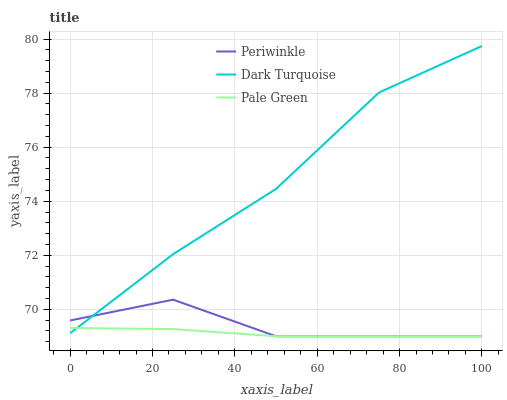Does Pale Green have the minimum area under the curve?
Answer yes or no. Yes. Does Dark Turquoise have the maximum area under the curve?
Answer yes or no. Yes. Does Periwinkle have the minimum area under the curve?
Answer yes or no. No. Does Periwinkle have the maximum area under the curve?
Answer yes or no. No. Is Pale Green the smoothest?
Answer yes or no. Yes. Is Dark Turquoise the roughest?
Answer yes or no. Yes. Is Periwinkle the smoothest?
Answer yes or no. No. Is Periwinkle the roughest?
Answer yes or no. No. Does Pale Green have the lowest value?
Answer yes or no. Yes. Does Dark Turquoise have the highest value?
Answer yes or no. Yes. Does Periwinkle have the highest value?
Answer yes or no. No. Does Pale Green intersect Dark Turquoise?
Answer yes or no. Yes. Is Pale Green less than Dark Turquoise?
Answer yes or no. No. Is Pale Green greater than Dark Turquoise?
Answer yes or no. No. 